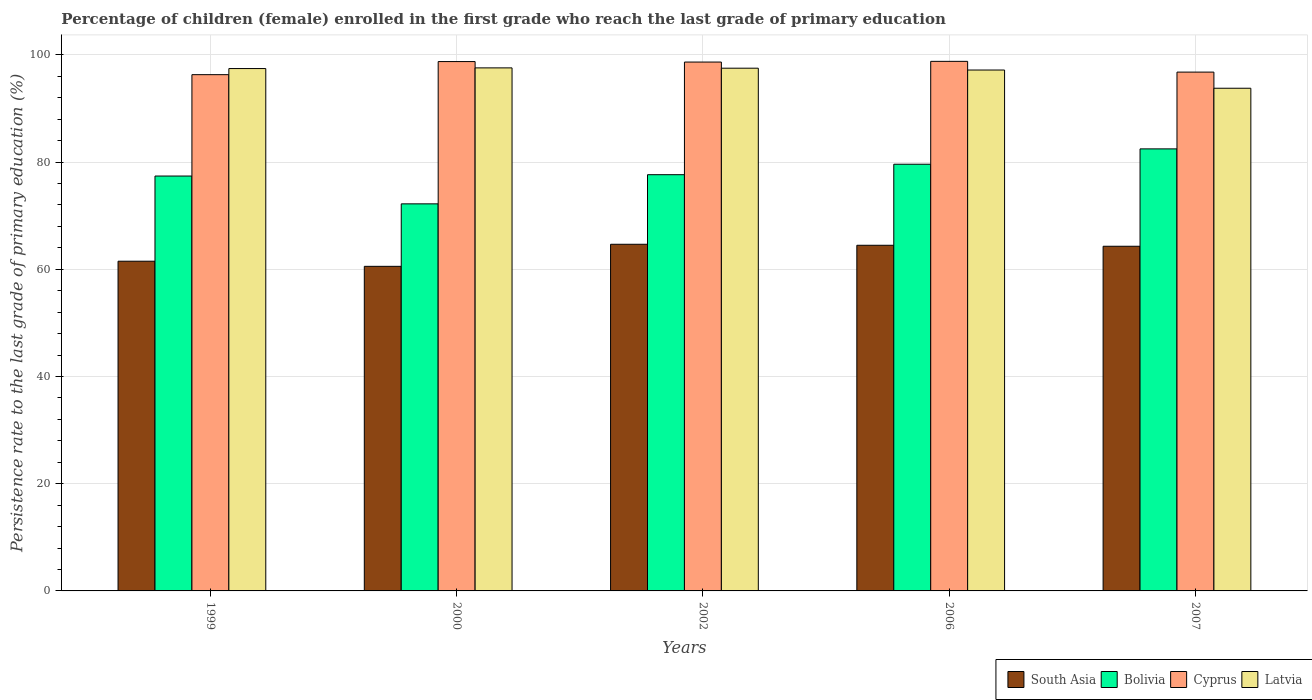Are the number of bars per tick equal to the number of legend labels?
Keep it short and to the point. Yes. Are the number of bars on each tick of the X-axis equal?
Your response must be concise. Yes. How many bars are there on the 3rd tick from the left?
Provide a short and direct response. 4. How many bars are there on the 1st tick from the right?
Offer a terse response. 4. In how many cases, is the number of bars for a given year not equal to the number of legend labels?
Give a very brief answer. 0. What is the persistence rate of children in Bolivia in 1999?
Provide a short and direct response. 77.39. Across all years, what is the maximum persistence rate of children in Cyprus?
Offer a terse response. 98.78. Across all years, what is the minimum persistence rate of children in Latvia?
Keep it short and to the point. 93.76. What is the total persistence rate of children in Cyprus in the graph?
Provide a short and direct response. 489.22. What is the difference between the persistence rate of children in Bolivia in 1999 and that in 2006?
Your response must be concise. -2.2. What is the difference between the persistence rate of children in Latvia in 2006 and the persistence rate of children in Cyprus in 1999?
Your response must be concise. 0.87. What is the average persistence rate of children in Bolivia per year?
Ensure brevity in your answer.  77.85. In the year 2007, what is the difference between the persistence rate of children in South Asia and persistence rate of children in Latvia?
Keep it short and to the point. -29.47. In how many years, is the persistence rate of children in Latvia greater than 24 %?
Provide a succinct answer. 5. What is the ratio of the persistence rate of children in Bolivia in 2000 to that in 2007?
Provide a short and direct response. 0.88. Is the difference between the persistence rate of children in South Asia in 1999 and 2002 greater than the difference between the persistence rate of children in Latvia in 1999 and 2002?
Make the answer very short. No. What is the difference between the highest and the second highest persistence rate of children in Cyprus?
Your response must be concise. 0.04. What is the difference between the highest and the lowest persistence rate of children in Latvia?
Offer a terse response. 3.8. Is the sum of the persistence rate of children in South Asia in 2000 and 2006 greater than the maximum persistence rate of children in Cyprus across all years?
Give a very brief answer. Yes. Is it the case that in every year, the sum of the persistence rate of children in Latvia and persistence rate of children in Bolivia is greater than the sum of persistence rate of children in South Asia and persistence rate of children in Cyprus?
Keep it short and to the point. No. What does the 1st bar from the left in 2002 represents?
Ensure brevity in your answer.  South Asia. What does the 4th bar from the right in 1999 represents?
Give a very brief answer. South Asia. How many bars are there?
Your answer should be very brief. 20. How many years are there in the graph?
Make the answer very short. 5. Does the graph contain any zero values?
Keep it short and to the point. No. What is the title of the graph?
Your answer should be very brief. Percentage of children (female) enrolled in the first grade who reach the last grade of primary education. What is the label or title of the X-axis?
Offer a terse response. Years. What is the label or title of the Y-axis?
Offer a very short reply. Persistence rate to the last grade of primary education (%). What is the Persistence rate to the last grade of primary education (%) of South Asia in 1999?
Keep it short and to the point. 61.5. What is the Persistence rate to the last grade of primary education (%) of Bolivia in 1999?
Ensure brevity in your answer.  77.39. What is the Persistence rate to the last grade of primary education (%) in Cyprus in 1999?
Keep it short and to the point. 96.29. What is the Persistence rate to the last grade of primary education (%) in Latvia in 1999?
Keep it short and to the point. 97.43. What is the Persistence rate to the last grade of primary education (%) in South Asia in 2000?
Offer a terse response. 60.54. What is the Persistence rate to the last grade of primary education (%) in Bolivia in 2000?
Make the answer very short. 72.2. What is the Persistence rate to the last grade of primary education (%) in Cyprus in 2000?
Keep it short and to the point. 98.74. What is the Persistence rate to the last grade of primary education (%) in Latvia in 2000?
Keep it short and to the point. 97.56. What is the Persistence rate to the last grade of primary education (%) in South Asia in 2002?
Ensure brevity in your answer.  64.66. What is the Persistence rate to the last grade of primary education (%) of Bolivia in 2002?
Your response must be concise. 77.64. What is the Persistence rate to the last grade of primary education (%) in Cyprus in 2002?
Your answer should be very brief. 98.64. What is the Persistence rate to the last grade of primary education (%) of Latvia in 2002?
Provide a short and direct response. 97.5. What is the Persistence rate to the last grade of primary education (%) in South Asia in 2006?
Make the answer very short. 64.47. What is the Persistence rate to the last grade of primary education (%) in Bolivia in 2006?
Make the answer very short. 79.59. What is the Persistence rate to the last grade of primary education (%) in Cyprus in 2006?
Keep it short and to the point. 98.78. What is the Persistence rate to the last grade of primary education (%) of Latvia in 2006?
Your answer should be compact. 97.16. What is the Persistence rate to the last grade of primary education (%) in South Asia in 2007?
Offer a terse response. 64.29. What is the Persistence rate to the last grade of primary education (%) in Bolivia in 2007?
Offer a terse response. 82.45. What is the Persistence rate to the last grade of primary education (%) in Cyprus in 2007?
Provide a short and direct response. 96.77. What is the Persistence rate to the last grade of primary education (%) of Latvia in 2007?
Ensure brevity in your answer.  93.76. Across all years, what is the maximum Persistence rate to the last grade of primary education (%) in South Asia?
Provide a short and direct response. 64.66. Across all years, what is the maximum Persistence rate to the last grade of primary education (%) of Bolivia?
Make the answer very short. 82.45. Across all years, what is the maximum Persistence rate to the last grade of primary education (%) of Cyprus?
Make the answer very short. 98.78. Across all years, what is the maximum Persistence rate to the last grade of primary education (%) in Latvia?
Your answer should be very brief. 97.56. Across all years, what is the minimum Persistence rate to the last grade of primary education (%) of South Asia?
Your answer should be very brief. 60.54. Across all years, what is the minimum Persistence rate to the last grade of primary education (%) of Bolivia?
Your answer should be very brief. 72.2. Across all years, what is the minimum Persistence rate to the last grade of primary education (%) in Cyprus?
Your answer should be compact. 96.29. Across all years, what is the minimum Persistence rate to the last grade of primary education (%) in Latvia?
Offer a very short reply. 93.76. What is the total Persistence rate to the last grade of primary education (%) in South Asia in the graph?
Offer a very short reply. 315.46. What is the total Persistence rate to the last grade of primary education (%) of Bolivia in the graph?
Provide a short and direct response. 389.25. What is the total Persistence rate to the last grade of primary education (%) in Cyprus in the graph?
Give a very brief answer. 489.22. What is the total Persistence rate to the last grade of primary education (%) of Latvia in the graph?
Your answer should be compact. 483.41. What is the difference between the Persistence rate to the last grade of primary education (%) of South Asia in 1999 and that in 2000?
Make the answer very short. 0.96. What is the difference between the Persistence rate to the last grade of primary education (%) in Bolivia in 1999 and that in 2000?
Keep it short and to the point. 5.19. What is the difference between the Persistence rate to the last grade of primary education (%) of Cyprus in 1999 and that in 2000?
Ensure brevity in your answer.  -2.44. What is the difference between the Persistence rate to the last grade of primary education (%) of Latvia in 1999 and that in 2000?
Your answer should be very brief. -0.12. What is the difference between the Persistence rate to the last grade of primary education (%) of South Asia in 1999 and that in 2002?
Make the answer very short. -3.16. What is the difference between the Persistence rate to the last grade of primary education (%) in Bolivia in 1999 and that in 2002?
Give a very brief answer. -0.25. What is the difference between the Persistence rate to the last grade of primary education (%) of Cyprus in 1999 and that in 2002?
Ensure brevity in your answer.  -2.35. What is the difference between the Persistence rate to the last grade of primary education (%) in Latvia in 1999 and that in 2002?
Make the answer very short. -0.07. What is the difference between the Persistence rate to the last grade of primary education (%) in South Asia in 1999 and that in 2006?
Offer a very short reply. -2.97. What is the difference between the Persistence rate to the last grade of primary education (%) in Bolivia in 1999 and that in 2006?
Ensure brevity in your answer.  -2.2. What is the difference between the Persistence rate to the last grade of primary education (%) in Cyprus in 1999 and that in 2006?
Make the answer very short. -2.48. What is the difference between the Persistence rate to the last grade of primary education (%) of Latvia in 1999 and that in 2006?
Provide a short and direct response. 0.27. What is the difference between the Persistence rate to the last grade of primary education (%) in South Asia in 1999 and that in 2007?
Give a very brief answer. -2.79. What is the difference between the Persistence rate to the last grade of primary education (%) in Bolivia in 1999 and that in 2007?
Give a very brief answer. -5.06. What is the difference between the Persistence rate to the last grade of primary education (%) in Cyprus in 1999 and that in 2007?
Give a very brief answer. -0.48. What is the difference between the Persistence rate to the last grade of primary education (%) in Latvia in 1999 and that in 2007?
Give a very brief answer. 3.67. What is the difference between the Persistence rate to the last grade of primary education (%) in South Asia in 2000 and that in 2002?
Your response must be concise. -4.11. What is the difference between the Persistence rate to the last grade of primary education (%) of Bolivia in 2000 and that in 2002?
Your response must be concise. -5.44. What is the difference between the Persistence rate to the last grade of primary education (%) in Cyprus in 2000 and that in 2002?
Your answer should be compact. 0.09. What is the difference between the Persistence rate to the last grade of primary education (%) in Latvia in 2000 and that in 2002?
Make the answer very short. 0.06. What is the difference between the Persistence rate to the last grade of primary education (%) of South Asia in 2000 and that in 2006?
Make the answer very short. -3.93. What is the difference between the Persistence rate to the last grade of primary education (%) of Bolivia in 2000 and that in 2006?
Give a very brief answer. -7.39. What is the difference between the Persistence rate to the last grade of primary education (%) in Cyprus in 2000 and that in 2006?
Offer a very short reply. -0.04. What is the difference between the Persistence rate to the last grade of primary education (%) of Latvia in 2000 and that in 2006?
Keep it short and to the point. 0.4. What is the difference between the Persistence rate to the last grade of primary education (%) of South Asia in 2000 and that in 2007?
Provide a short and direct response. -3.75. What is the difference between the Persistence rate to the last grade of primary education (%) in Bolivia in 2000 and that in 2007?
Provide a succinct answer. -10.25. What is the difference between the Persistence rate to the last grade of primary education (%) of Cyprus in 2000 and that in 2007?
Make the answer very short. 1.97. What is the difference between the Persistence rate to the last grade of primary education (%) in Latvia in 2000 and that in 2007?
Keep it short and to the point. 3.8. What is the difference between the Persistence rate to the last grade of primary education (%) of South Asia in 2002 and that in 2006?
Offer a very short reply. 0.18. What is the difference between the Persistence rate to the last grade of primary education (%) in Bolivia in 2002 and that in 2006?
Your answer should be very brief. -1.95. What is the difference between the Persistence rate to the last grade of primary education (%) of Cyprus in 2002 and that in 2006?
Offer a very short reply. -0.13. What is the difference between the Persistence rate to the last grade of primary education (%) of Latvia in 2002 and that in 2006?
Offer a terse response. 0.34. What is the difference between the Persistence rate to the last grade of primary education (%) of South Asia in 2002 and that in 2007?
Your answer should be very brief. 0.37. What is the difference between the Persistence rate to the last grade of primary education (%) of Bolivia in 2002 and that in 2007?
Your answer should be very brief. -4.81. What is the difference between the Persistence rate to the last grade of primary education (%) in Cyprus in 2002 and that in 2007?
Your answer should be compact. 1.87. What is the difference between the Persistence rate to the last grade of primary education (%) in Latvia in 2002 and that in 2007?
Make the answer very short. 3.74. What is the difference between the Persistence rate to the last grade of primary education (%) in South Asia in 2006 and that in 2007?
Offer a terse response. 0.18. What is the difference between the Persistence rate to the last grade of primary education (%) of Bolivia in 2006 and that in 2007?
Give a very brief answer. -2.86. What is the difference between the Persistence rate to the last grade of primary education (%) of Cyprus in 2006 and that in 2007?
Ensure brevity in your answer.  2. What is the difference between the Persistence rate to the last grade of primary education (%) in Latvia in 2006 and that in 2007?
Provide a succinct answer. 3.4. What is the difference between the Persistence rate to the last grade of primary education (%) in South Asia in 1999 and the Persistence rate to the last grade of primary education (%) in Bolivia in 2000?
Offer a terse response. -10.7. What is the difference between the Persistence rate to the last grade of primary education (%) in South Asia in 1999 and the Persistence rate to the last grade of primary education (%) in Cyprus in 2000?
Your answer should be very brief. -37.24. What is the difference between the Persistence rate to the last grade of primary education (%) of South Asia in 1999 and the Persistence rate to the last grade of primary education (%) of Latvia in 2000?
Give a very brief answer. -36.06. What is the difference between the Persistence rate to the last grade of primary education (%) in Bolivia in 1999 and the Persistence rate to the last grade of primary education (%) in Cyprus in 2000?
Offer a terse response. -21.35. What is the difference between the Persistence rate to the last grade of primary education (%) of Bolivia in 1999 and the Persistence rate to the last grade of primary education (%) of Latvia in 2000?
Your response must be concise. -20.17. What is the difference between the Persistence rate to the last grade of primary education (%) in Cyprus in 1999 and the Persistence rate to the last grade of primary education (%) in Latvia in 2000?
Your answer should be compact. -1.26. What is the difference between the Persistence rate to the last grade of primary education (%) in South Asia in 1999 and the Persistence rate to the last grade of primary education (%) in Bolivia in 2002?
Keep it short and to the point. -16.14. What is the difference between the Persistence rate to the last grade of primary education (%) in South Asia in 1999 and the Persistence rate to the last grade of primary education (%) in Cyprus in 2002?
Provide a succinct answer. -37.15. What is the difference between the Persistence rate to the last grade of primary education (%) in South Asia in 1999 and the Persistence rate to the last grade of primary education (%) in Latvia in 2002?
Provide a succinct answer. -36. What is the difference between the Persistence rate to the last grade of primary education (%) of Bolivia in 1999 and the Persistence rate to the last grade of primary education (%) of Cyprus in 2002?
Offer a very short reply. -21.26. What is the difference between the Persistence rate to the last grade of primary education (%) in Bolivia in 1999 and the Persistence rate to the last grade of primary education (%) in Latvia in 2002?
Keep it short and to the point. -20.12. What is the difference between the Persistence rate to the last grade of primary education (%) in Cyprus in 1999 and the Persistence rate to the last grade of primary education (%) in Latvia in 2002?
Your answer should be compact. -1.21. What is the difference between the Persistence rate to the last grade of primary education (%) of South Asia in 1999 and the Persistence rate to the last grade of primary education (%) of Bolivia in 2006?
Your response must be concise. -18.09. What is the difference between the Persistence rate to the last grade of primary education (%) of South Asia in 1999 and the Persistence rate to the last grade of primary education (%) of Cyprus in 2006?
Ensure brevity in your answer.  -37.28. What is the difference between the Persistence rate to the last grade of primary education (%) of South Asia in 1999 and the Persistence rate to the last grade of primary education (%) of Latvia in 2006?
Keep it short and to the point. -35.66. What is the difference between the Persistence rate to the last grade of primary education (%) in Bolivia in 1999 and the Persistence rate to the last grade of primary education (%) in Cyprus in 2006?
Offer a terse response. -21.39. What is the difference between the Persistence rate to the last grade of primary education (%) in Bolivia in 1999 and the Persistence rate to the last grade of primary education (%) in Latvia in 2006?
Your answer should be compact. -19.77. What is the difference between the Persistence rate to the last grade of primary education (%) in Cyprus in 1999 and the Persistence rate to the last grade of primary education (%) in Latvia in 2006?
Ensure brevity in your answer.  -0.87. What is the difference between the Persistence rate to the last grade of primary education (%) in South Asia in 1999 and the Persistence rate to the last grade of primary education (%) in Bolivia in 2007?
Your answer should be compact. -20.95. What is the difference between the Persistence rate to the last grade of primary education (%) of South Asia in 1999 and the Persistence rate to the last grade of primary education (%) of Cyprus in 2007?
Provide a short and direct response. -35.27. What is the difference between the Persistence rate to the last grade of primary education (%) of South Asia in 1999 and the Persistence rate to the last grade of primary education (%) of Latvia in 2007?
Your answer should be very brief. -32.26. What is the difference between the Persistence rate to the last grade of primary education (%) of Bolivia in 1999 and the Persistence rate to the last grade of primary education (%) of Cyprus in 2007?
Offer a very short reply. -19.39. What is the difference between the Persistence rate to the last grade of primary education (%) of Bolivia in 1999 and the Persistence rate to the last grade of primary education (%) of Latvia in 2007?
Offer a very short reply. -16.38. What is the difference between the Persistence rate to the last grade of primary education (%) in Cyprus in 1999 and the Persistence rate to the last grade of primary education (%) in Latvia in 2007?
Your answer should be compact. 2.53. What is the difference between the Persistence rate to the last grade of primary education (%) in South Asia in 2000 and the Persistence rate to the last grade of primary education (%) in Bolivia in 2002?
Give a very brief answer. -17.09. What is the difference between the Persistence rate to the last grade of primary education (%) in South Asia in 2000 and the Persistence rate to the last grade of primary education (%) in Cyprus in 2002?
Provide a short and direct response. -38.1. What is the difference between the Persistence rate to the last grade of primary education (%) of South Asia in 2000 and the Persistence rate to the last grade of primary education (%) of Latvia in 2002?
Your answer should be very brief. -36.96. What is the difference between the Persistence rate to the last grade of primary education (%) of Bolivia in 2000 and the Persistence rate to the last grade of primary education (%) of Cyprus in 2002?
Your response must be concise. -26.45. What is the difference between the Persistence rate to the last grade of primary education (%) in Bolivia in 2000 and the Persistence rate to the last grade of primary education (%) in Latvia in 2002?
Provide a succinct answer. -25.3. What is the difference between the Persistence rate to the last grade of primary education (%) in Cyprus in 2000 and the Persistence rate to the last grade of primary education (%) in Latvia in 2002?
Provide a succinct answer. 1.24. What is the difference between the Persistence rate to the last grade of primary education (%) of South Asia in 2000 and the Persistence rate to the last grade of primary education (%) of Bolivia in 2006?
Provide a succinct answer. -19.05. What is the difference between the Persistence rate to the last grade of primary education (%) in South Asia in 2000 and the Persistence rate to the last grade of primary education (%) in Cyprus in 2006?
Provide a succinct answer. -38.23. What is the difference between the Persistence rate to the last grade of primary education (%) of South Asia in 2000 and the Persistence rate to the last grade of primary education (%) of Latvia in 2006?
Your answer should be compact. -36.62. What is the difference between the Persistence rate to the last grade of primary education (%) in Bolivia in 2000 and the Persistence rate to the last grade of primary education (%) in Cyprus in 2006?
Ensure brevity in your answer.  -26.58. What is the difference between the Persistence rate to the last grade of primary education (%) of Bolivia in 2000 and the Persistence rate to the last grade of primary education (%) of Latvia in 2006?
Keep it short and to the point. -24.96. What is the difference between the Persistence rate to the last grade of primary education (%) in Cyprus in 2000 and the Persistence rate to the last grade of primary education (%) in Latvia in 2006?
Your answer should be very brief. 1.58. What is the difference between the Persistence rate to the last grade of primary education (%) in South Asia in 2000 and the Persistence rate to the last grade of primary education (%) in Bolivia in 2007?
Your answer should be compact. -21.91. What is the difference between the Persistence rate to the last grade of primary education (%) in South Asia in 2000 and the Persistence rate to the last grade of primary education (%) in Cyprus in 2007?
Provide a succinct answer. -36.23. What is the difference between the Persistence rate to the last grade of primary education (%) of South Asia in 2000 and the Persistence rate to the last grade of primary education (%) of Latvia in 2007?
Ensure brevity in your answer.  -33.22. What is the difference between the Persistence rate to the last grade of primary education (%) of Bolivia in 2000 and the Persistence rate to the last grade of primary education (%) of Cyprus in 2007?
Offer a terse response. -24.58. What is the difference between the Persistence rate to the last grade of primary education (%) of Bolivia in 2000 and the Persistence rate to the last grade of primary education (%) of Latvia in 2007?
Your answer should be very brief. -21.57. What is the difference between the Persistence rate to the last grade of primary education (%) in Cyprus in 2000 and the Persistence rate to the last grade of primary education (%) in Latvia in 2007?
Make the answer very short. 4.98. What is the difference between the Persistence rate to the last grade of primary education (%) in South Asia in 2002 and the Persistence rate to the last grade of primary education (%) in Bolivia in 2006?
Provide a succinct answer. -14.93. What is the difference between the Persistence rate to the last grade of primary education (%) in South Asia in 2002 and the Persistence rate to the last grade of primary education (%) in Cyprus in 2006?
Offer a terse response. -34.12. What is the difference between the Persistence rate to the last grade of primary education (%) of South Asia in 2002 and the Persistence rate to the last grade of primary education (%) of Latvia in 2006?
Provide a succinct answer. -32.5. What is the difference between the Persistence rate to the last grade of primary education (%) of Bolivia in 2002 and the Persistence rate to the last grade of primary education (%) of Cyprus in 2006?
Your response must be concise. -21.14. What is the difference between the Persistence rate to the last grade of primary education (%) of Bolivia in 2002 and the Persistence rate to the last grade of primary education (%) of Latvia in 2006?
Provide a succinct answer. -19.52. What is the difference between the Persistence rate to the last grade of primary education (%) of Cyprus in 2002 and the Persistence rate to the last grade of primary education (%) of Latvia in 2006?
Your answer should be very brief. 1.49. What is the difference between the Persistence rate to the last grade of primary education (%) in South Asia in 2002 and the Persistence rate to the last grade of primary education (%) in Bolivia in 2007?
Your answer should be very brief. -17.79. What is the difference between the Persistence rate to the last grade of primary education (%) in South Asia in 2002 and the Persistence rate to the last grade of primary education (%) in Cyprus in 2007?
Offer a terse response. -32.11. What is the difference between the Persistence rate to the last grade of primary education (%) in South Asia in 2002 and the Persistence rate to the last grade of primary education (%) in Latvia in 2007?
Your answer should be very brief. -29.1. What is the difference between the Persistence rate to the last grade of primary education (%) in Bolivia in 2002 and the Persistence rate to the last grade of primary education (%) in Cyprus in 2007?
Provide a succinct answer. -19.14. What is the difference between the Persistence rate to the last grade of primary education (%) in Bolivia in 2002 and the Persistence rate to the last grade of primary education (%) in Latvia in 2007?
Offer a terse response. -16.13. What is the difference between the Persistence rate to the last grade of primary education (%) of Cyprus in 2002 and the Persistence rate to the last grade of primary education (%) of Latvia in 2007?
Your response must be concise. 4.88. What is the difference between the Persistence rate to the last grade of primary education (%) in South Asia in 2006 and the Persistence rate to the last grade of primary education (%) in Bolivia in 2007?
Give a very brief answer. -17.98. What is the difference between the Persistence rate to the last grade of primary education (%) in South Asia in 2006 and the Persistence rate to the last grade of primary education (%) in Cyprus in 2007?
Offer a terse response. -32.3. What is the difference between the Persistence rate to the last grade of primary education (%) in South Asia in 2006 and the Persistence rate to the last grade of primary education (%) in Latvia in 2007?
Offer a very short reply. -29.29. What is the difference between the Persistence rate to the last grade of primary education (%) in Bolivia in 2006 and the Persistence rate to the last grade of primary education (%) in Cyprus in 2007?
Give a very brief answer. -17.18. What is the difference between the Persistence rate to the last grade of primary education (%) in Bolivia in 2006 and the Persistence rate to the last grade of primary education (%) in Latvia in 2007?
Keep it short and to the point. -14.17. What is the difference between the Persistence rate to the last grade of primary education (%) in Cyprus in 2006 and the Persistence rate to the last grade of primary education (%) in Latvia in 2007?
Your response must be concise. 5.01. What is the average Persistence rate to the last grade of primary education (%) of South Asia per year?
Keep it short and to the point. 63.09. What is the average Persistence rate to the last grade of primary education (%) of Bolivia per year?
Your answer should be compact. 77.85. What is the average Persistence rate to the last grade of primary education (%) of Cyprus per year?
Give a very brief answer. 97.84. What is the average Persistence rate to the last grade of primary education (%) of Latvia per year?
Make the answer very short. 96.68. In the year 1999, what is the difference between the Persistence rate to the last grade of primary education (%) in South Asia and Persistence rate to the last grade of primary education (%) in Bolivia?
Your answer should be very brief. -15.89. In the year 1999, what is the difference between the Persistence rate to the last grade of primary education (%) of South Asia and Persistence rate to the last grade of primary education (%) of Cyprus?
Offer a very short reply. -34.8. In the year 1999, what is the difference between the Persistence rate to the last grade of primary education (%) of South Asia and Persistence rate to the last grade of primary education (%) of Latvia?
Offer a very short reply. -35.94. In the year 1999, what is the difference between the Persistence rate to the last grade of primary education (%) of Bolivia and Persistence rate to the last grade of primary education (%) of Cyprus?
Your response must be concise. -18.91. In the year 1999, what is the difference between the Persistence rate to the last grade of primary education (%) of Bolivia and Persistence rate to the last grade of primary education (%) of Latvia?
Your response must be concise. -20.05. In the year 1999, what is the difference between the Persistence rate to the last grade of primary education (%) of Cyprus and Persistence rate to the last grade of primary education (%) of Latvia?
Offer a very short reply. -1.14. In the year 2000, what is the difference between the Persistence rate to the last grade of primary education (%) in South Asia and Persistence rate to the last grade of primary education (%) in Bolivia?
Make the answer very short. -11.65. In the year 2000, what is the difference between the Persistence rate to the last grade of primary education (%) in South Asia and Persistence rate to the last grade of primary education (%) in Cyprus?
Your answer should be compact. -38.19. In the year 2000, what is the difference between the Persistence rate to the last grade of primary education (%) in South Asia and Persistence rate to the last grade of primary education (%) in Latvia?
Offer a very short reply. -37.01. In the year 2000, what is the difference between the Persistence rate to the last grade of primary education (%) in Bolivia and Persistence rate to the last grade of primary education (%) in Cyprus?
Give a very brief answer. -26.54. In the year 2000, what is the difference between the Persistence rate to the last grade of primary education (%) of Bolivia and Persistence rate to the last grade of primary education (%) of Latvia?
Give a very brief answer. -25.36. In the year 2000, what is the difference between the Persistence rate to the last grade of primary education (%) of Cyprus and Persistence rate to the last grade of primary education (%) of Latvia?
Your answer should be compact. 1.18. In the year 2002, what is the difference between the Persistence rate to the last grade of primary education (%) of South Asia and Persistence rate to the last grade of primary education (%) of Bolivia?
Ensure brevity in your answer.  -12.98. In the year 2002, what is the difference between the Persistence rate to the last grade of primary education (%) of South Asia and Persistence rate to the last grade of primary education (%) of Cyprus?
Make the answer very short. -33.99. In the year 2002, what is the difference between the Persistence rate to the last grade of primary education (%) of South Asia and Persistence rate to the last grade of primary education (%) of Latvia?
Keep it short and to the point. -32.84. In the year 2002, what is the difference between the Persistence rate to the last grade of primary education (%) of Bolivia and Persistence rate to the last grade of primary education (%) of Cyprus?
Offer a terse response. -21.01. In the year 2002, what is the difference between the Persistence rate to the last grade of primary education (%) of Bolivia and Persistence rate to the last grade of primary education (%) of Latvia?
Give a very brief answer. -19.86. In the year 2002, what is the difference between the Persistence rate to the last grade of primary education (%) of Cyprus and Persistence rate to the last grade of primary education (%) of Latvia?
Offer a very short reply. 1.14. In the year 2006, what is the difference between the Persistence rate to the last grade of primary education (%) in South Asia and Persistence rate to the last grade of primary education (%) in Bolivia?
Keep it short and to the point. -15.12. In the year 2006, what is the difference between the Persistence rate to the last grade of primary education (%) of South Asia and Persistence rate to the last grade of primary education (%) of Cyprus?
Give a very brief answer. -34.3. In the year 2006, what is the difference between the Persistence rate to the last grade of primary education (%) of South Asia and Persistence rate to the last grade of primary education (%) of Latvia?
Ensure brevity in your answer.  -32.69. In the year 2006, what is the difference between the Persistence rate to the last grade of primary education (%) in Bolivia and Persistence rate to the last grade of primary education (%) in Cyprus?
Your answer should be compact. -19.19. In the year 2006, what is the difference between the Persistence rate to the last grade of primary education (%) of Bolivia and Persistence rate to the last grade of primary education (%) of Latvia?
Ensure brevity in your answer.  -17.57. In the year 2006, what is the difference between the Persistence rate to the last grade of primary education (%) of Cyprus and Persistence rate to the last grade of primary education (%) of Latvia?
Your answer should be compact. 1.62. In the year 2007, what is the difference between the Persistence rate to the last grade of primary education (%) in South Asia and Persistence rate to the last grade of primary education (%) in Bolivia?
Ensure brevity in your answer.  -18.16. In the year 2007, what is the difference between the Persistence rate to the last grade of primary education (%) in South Asia and Persistence rate to the last grade of primary education (%) in Cyprus?
Ensure brevity in your answer.  -32.48. In the year 2007, what is the difference between the Persistence rate to the last grade of primary education (%) of South Asia and Persistence rate to the last grade of primary education (%) of Latvia?
Your answer should be very brief. -29.47. In the year 2007, what is the difference between the Persistence rate to the last grade of primary education (%) in Bolivia and Persistence rate to the last grade of primary education (%) in Cyprus?
Your response must be concise. -14.32. In the year 2007, what is the difference between the Persistence rate to the last grade of primary education (%) in Bolivia and Persistence rate to the last grade of primary education (%) in Latvia?
Ensure brevity in your answer.  -11.31. In the year 2007, what is the difference between the Persistence rate to the last grade of primary education (%) of Cyprus and Persistence rate to the last grade of primary education (%) of Latvia?
Make the answer very short. 3.01. What is the ratio of the Persistence rate to the last grade of primary education (%) in South Asia in 1999 to that in 2000?
Your response must be concise. 1.02. What is the ratio of the Persistence rate to the last grade of primary education (%) of Bolivia in 1999 to that in 2000?
Your response must be concise. 1.07. What is the ratio of the Persistence rate to the last grade of primary education (%) in Cyprus in 1999 to that in 2000?
Keep it short and to the point. 0.98. What is the ratio of the Persistence rate to the last grade of primary education (%) of Latvia in 1999 to that in 2000?
Give a very brief answer. 1. What is the ratio of the Persistence rate to the last grade of primary education (%) in South Asia in 1999 to that in 2002?
Give a very brief answer. 0.95. What is the ratio of the Persistence rate to the last grade of primary education (%) in Bolivia in 1999 to that in 2002?
Your response must be concise. 1. What is the ratio of the Persistence rate to the last grade of primary education (%) in Cyprus in 1999 to that in 2002?
Provide a succinct answer. 0.98. What is the ratio of the Persistence rate to the last grade of primary education (%) of South Asia in 1999 to that in 2006?
Your response must be concise. 0.95. What is the ratio of the Persistence rate to the last grade of primary education (%) of Bolivia in 1999 to that in 2006?
Your response must be concise. 0.97. What is the ratio of the Persistence rate to the last grade of primary education (%) in Cyprus in 1999 to that in 2006?
Offer a very short reply. 0.97. What is the ratio of the Persistence rate to the last grade of primary education (%) of South Asia in 1999 to that in 2007?
Your answer should be very brief. 0.96. What is the ratio of the Persistence rate to the last grade of primary education (%) in Bolivia in 1999 to that in 2007?
Your answer should be very brief. 0.94. What is the ratio of the Persistence rate to the last grade of primary education (%) in Latvia in 1999 to that in 2007?
Make the answer very short. 1.04. What is the ratio of the Persistence rate to the last grade of primary education (%) in South Asia in 2000 to that in 2002?
Provide a succinct answer. 0.94. What is the ratio of the Persistence rate to the last grade of primary education (%) in Bolivia in 2000 to that in 2002?
Keep it short and to the point. 0.93. What is the ratio of the Persistence rate to the last grade of primary education (%) in Cyprus in 2000 to that in 2002?
Make the answer very short. 1. What is the ratio of the Persistence rate to the last grade of primary education (%) in Latvia in 2000 to that in 2002?
Ensure brevity in your answer.  1. What is the ratio of the Persistence rate to the last grade of primary education (%) of South Asia in 2000 to that in 2006?
Provide a short and direct response. 0.94. What is the ratio of the Persistence rate to the last grade of primary education (%) in Bolivia in 2000 to that in 2006?
Give a very brief answer. 0.91. What is the ratio of the Persistence rate to the last grade of primary education (%) of Cyprus in 2000 to that in 2006?
Give a very brief answer. 1. What is the ratio of the Persistence rate to the last grade of primary education (%) of Latvia in 2000 to that in 2006?
Make the answer very short. 1. What is the ratio of the Persistence rate to the last grade of primary education (%) in South Asia in 2000 to that in 2007?
Keep it short and to the point. 0.94. What is the ratio of the Persistence rate to the last grade of primary education (%) of Bolivia in 2000 to that in 2007?
Keep it short and to the point. 0.88. What is the ratio of the Persistence rate to the last grade of primary education (%) of Cyprus in 2000 to that in 2007?
Give a very brief answer. 1.02. What is the ratio of the Persistence rate to the last grade of primary education (%) in Latvia in 2000 to that in 2007?
Offer a very short reply. 1.04. What is the ratio of the Persistence rate to the last grade of primary education (%) of Bolivia in 2002 to that in 2006?
Give a very brief answer. 0.98. What is the ratio of the Persistence rate to the last grade of primary education (%) of Bolivia in 2002 to that in 2007?
Provide a short and direct response. 0.94. What is the ratio of the Persistence rate to the last grade of primary education (%) of Cyprus in 2002 to that in 2007?
Provide a short and direct response. 1.02. What is the ratio of the Persistence rate to the last grade of primary education (%) in Latvia in 2002 to that in 2007?
Provide a short and direct response. 1.04. What is the ratio of the Persistence rate to the last grade of primary education (%) of South Asia in 2006 to that in 2007?
Offer a very short reply. 1. What is the ratio of the Persistence rate to the last grade of primary education (%) of Bolivia in 2006 to that in 2007?
Provide a short and direct response. 0.97. What is the ratio of the Persistence rate to the last grade of primary education (%) in Cyprus in 2006 to that in 2007?
Your response must be concise. 1.02. What is the ratio of the Persistence rate to the last grade of primary education (%) of Latvia in 2006 to that in 2007?
Make the answer very short. 1.04. What is the difference between the highest and the second highest Persistence rate to the last grade of primary education (%) in South Asia?
Keep it short and to the point. 0.18. What is the difference between the highest and the second highest Persistence rate to the last grade of primary education (%) in Bolivia?
Offer a terse response. 2.86. What is the difference between the highest and the second highest Persistence rate to the last grade of primary education (%) of Cyprus?
Offer a terse response. 0.04. What is the difference between the highest and the second highest Persistence rate to the last grade of primary education (%) in Latvia?
Ensure brevity in your answer.  0.06. What is the difference between the highest and the lowest Persistence rate to the last grade of primary education (%) in South Asia?
Your answer should be very brief. 4.11. What is the difference between the highest and the lowest Persistence rate to the last grade of primary education (%) of Bolivia?
Your answer should be very brief. 10.25. What is the difference between the highest and the lowest Persistence rate to the last grade of primary education (%) of Cyprus?
Your response must be concise. 2.48. What is the difference between the highest and the lowest Persistence rate to the last grade of primary education (%) in Latvia?
Provide a succinct answer. 3.8. 